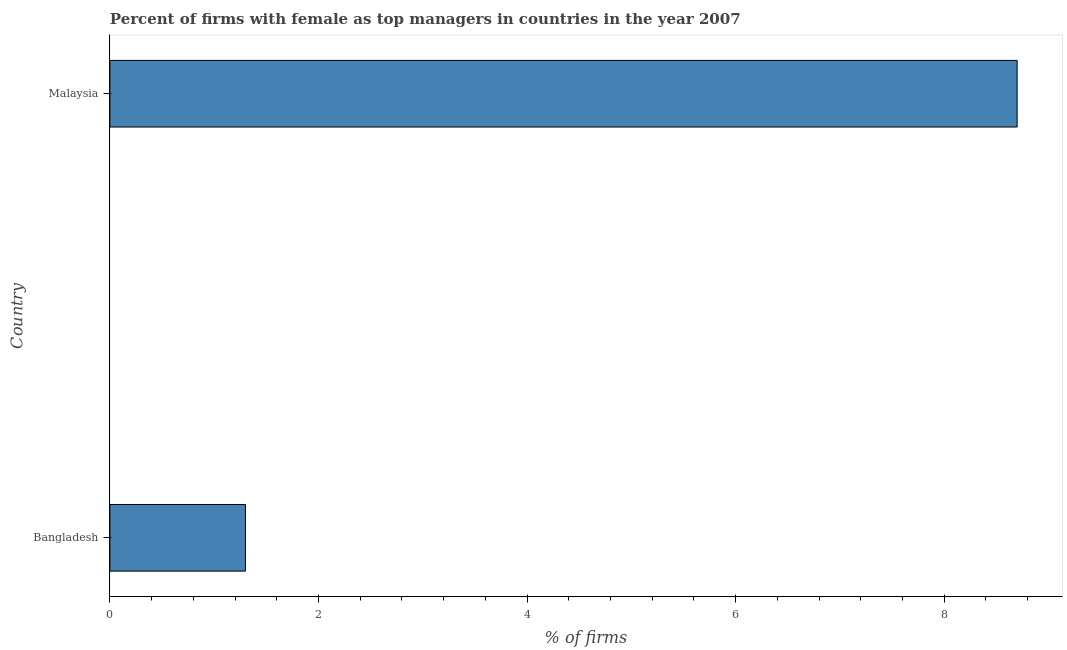Does the graph contain any zero values?
Keep it short and to the point. No. Does the graph contain grids?
Your response must be concise. No. What is the title of the graph?
Provide a succinct answer. Percent of firms with female as top managers in countries in the year 2007. What is the label or title of the X-axis?
Ensure brevity in your answer.  % of firms. Across all countries, what is the maximum percentage of firms with female as top manager?
Offer a terse response. 8.7. Across all countries, what is the minimum percentage of firms with female as top manager?
Ensure brevity in your answer.  1.3. In which country was the percentage of firms with female as top manager maximum?
Your answer should be very brief. Malaysia. In which country was the percentage of firms with female as top manager minimum?
Give a very brief answer. Bangladesh. What is the sum of the percentage of firms with female as top manager?
Provide a short and direct response. 10. What is the difference between the percentage of firms with female as top manager in Bangladesh and Malaysia?
Make the answer very short. -7.4. What is the average percentage of firms with female as top manager per country?
Ensure brevity in your answer.  5. What is the median percentage of firms with female as top manager?
Make the answer very short. 5. In how many countries, is the percentage of firms with female as top manager greater than 2 %?
Your answer should be compact. 1. What is the ratio of the percentage of firms with female as top manager in Bangladesh to that in Malaysia?
Your answer should be compact. 0.15. In how many countries, is the percentage of firms with female as top manager greater than the average percentage of firms with female as top manager taken over all countries?
Ensure brevity in your answer.  1. Are the values on the major ticks of X-axis written in scientific E-notation?
Your answer should be very brief. No. What is the % of firms of Malaysia?
Ensure brevity in your answer.  8.7. What is the ratio of the % of firms in Bangladesh to that in Malaysia?
Keep it short and to the point. 0.15. 